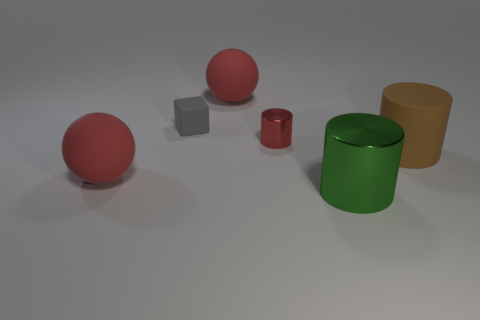Add 3 rubber spheres. How many objects exist? 9 Subtract all big cylinders. How many cylinders are left? 1 Subtract all red cylinders. How many cylinders are left? 2 Subtract all spheres. How many objects are left? 4 Subtract all matte cylinders. Subtract all large metal objects. How many objects are left? 4 Add 4 cylinders. How many cylinders are left? 7 Add 2 big green metal balls. How many big green metal balls exist? 2 Subtract 0 blue balls. How many objects are left? 6 Subtract all cyan balls. Subtract all green cylinders. How many balls are left? 2 